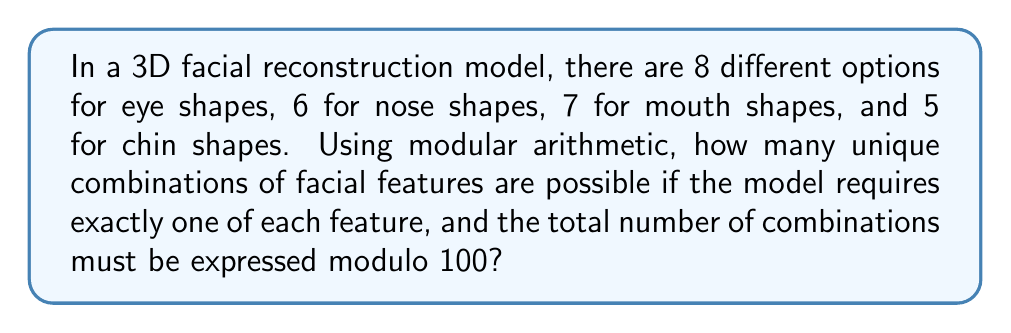Can you solve this math problem? Let's approach this step-by-step:

1) First, we need to calculate the total number of possible combinations without the modulo operation:

   $$8 \times 6 \times 7 \times 5 = 1680$$

2) Now, we need to express this result modulo 100. In modular arithmetic, this is equivalent to finding the remainder when 1680 is divided by 100.

3) We can use the division algorithm:

   $$1680 = 16 \times 100 + 80$$

4) Therefore, 1680 ≡ 80 (mod 100)

5) This means that when we express the number of combinations modulo 100, the result is 80.

In the context of facial reconstruction, this modular result could be useful for categorizing or indexing different facial models within a limited range (0-99), which might be beneficial for efficient storage or quick retrieval in a database system.
Answer: 80 